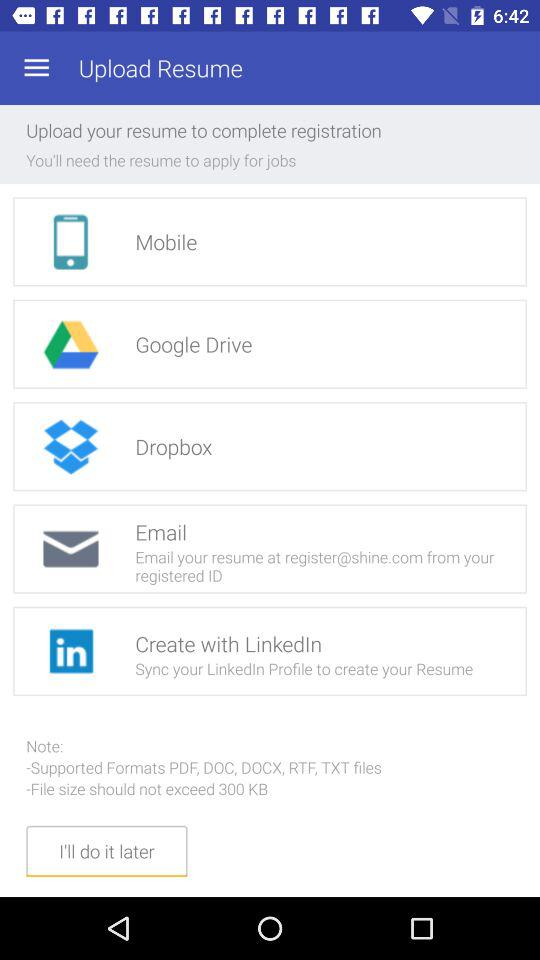How many file formats are supported?
Answer the question using a single word or phrase. 5 